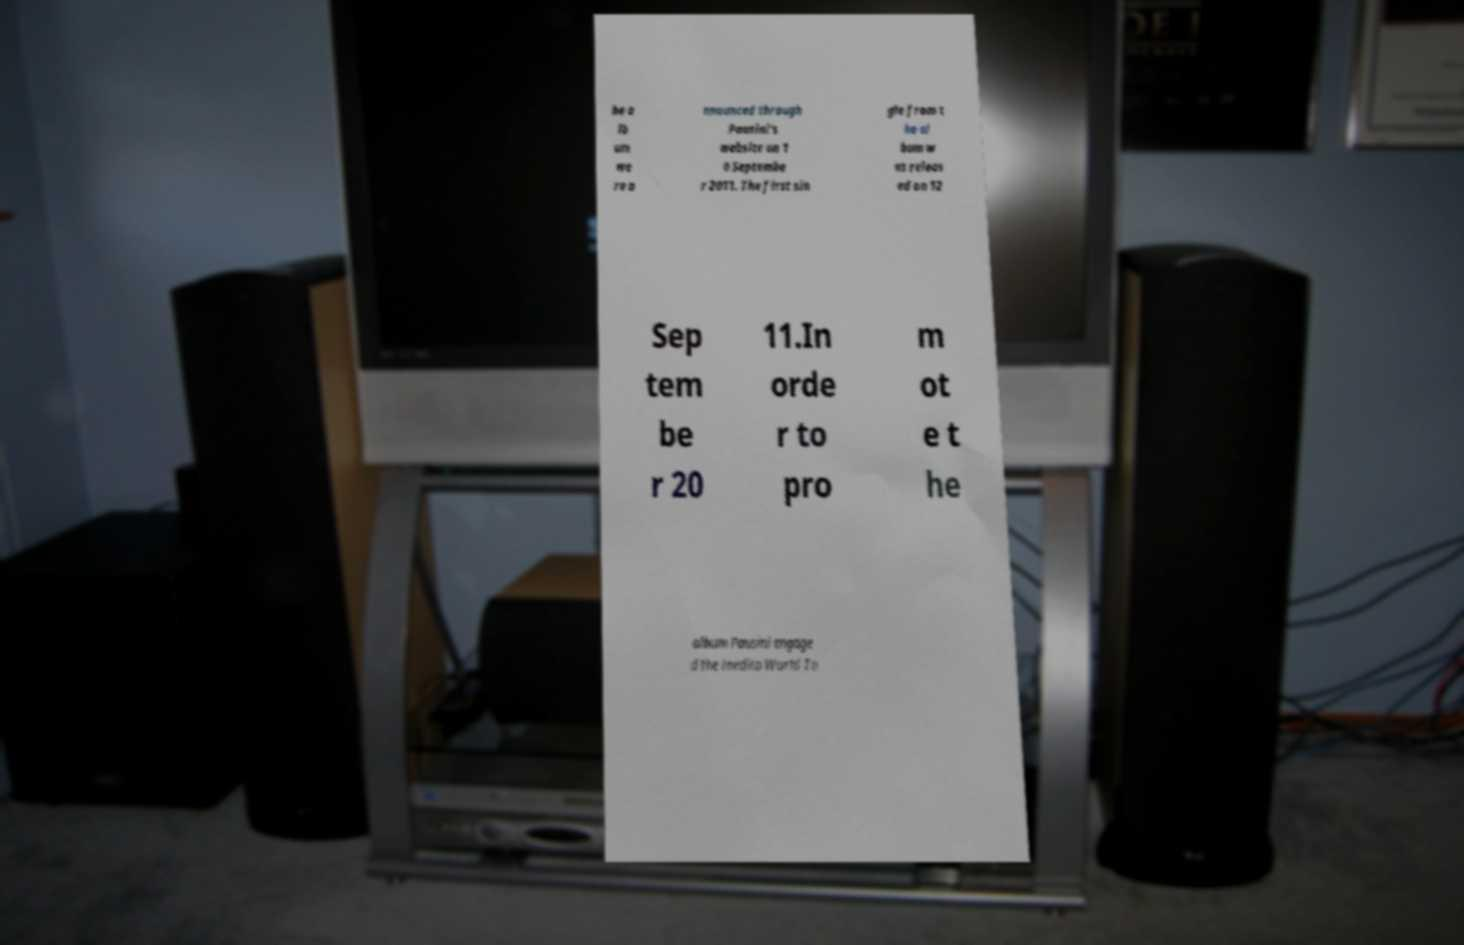Please identify and transcribe the text found in this image. he a lb um we re a nnounced through Pausini's website on 1 0 Septembe r 2011. The first sin gle from t he al bum w as releas ed on 12 Sep tem be r 20 11.In orde r to pro m ot e t he album Pausini engage d the Inedito World To 